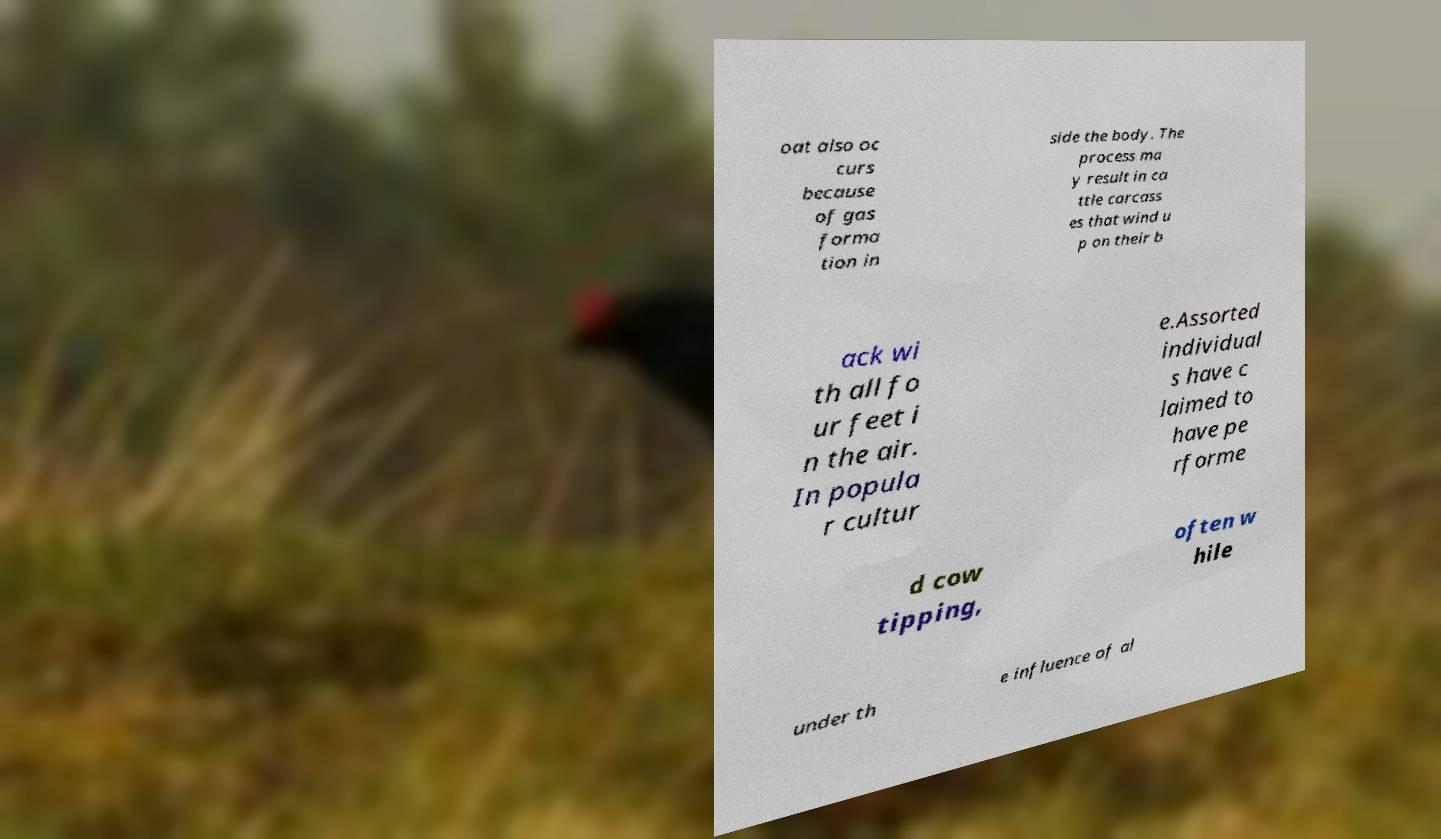For documentation purposes, I need the text within this image transcribed. Could you provide that? oat also oc curs because of gas forma tion in side the body. The process ma y result in ca ttle carcass es that wind u p on their b ack wi th all fo ur feet i n the air. In popula r cultur e.Assorted individual s have c laimed to have pe rforme d cow tipping, often w hile under th e influence of al 